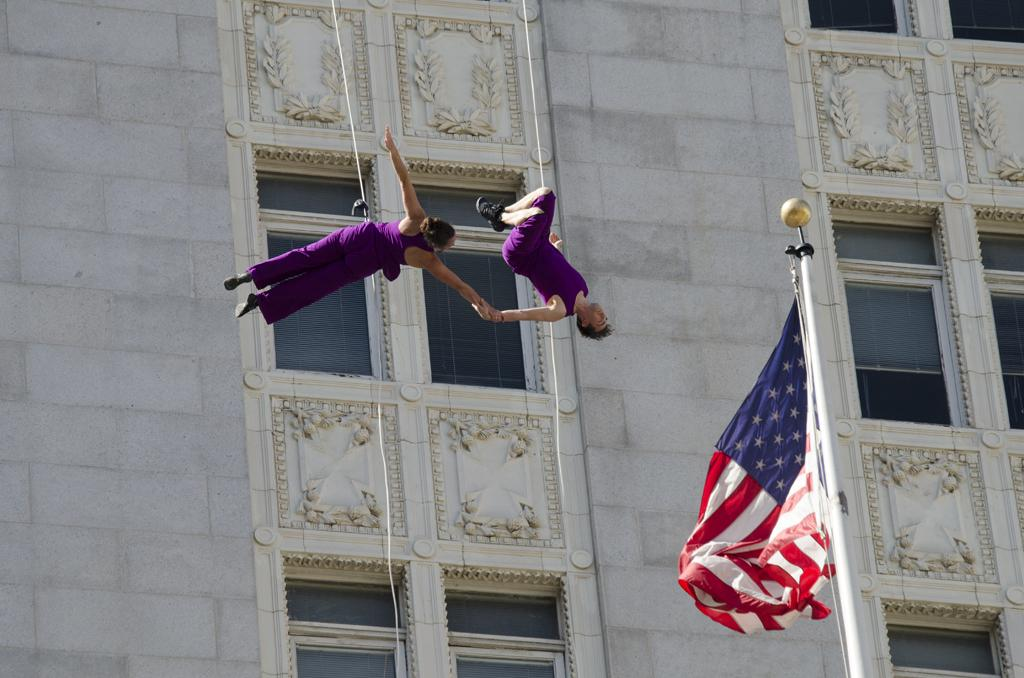What are the two people in the image doing? A: The two people are in the air, which suggests they might be flying or performing an activity that involves being suspended. What can be seen connecting the people to the ground or another object in the image? Ropes are visible in the image, which might be used to support or suspend the people. What is the background of the image composed of? There is a wall in the image, which could be the surface the people are attached to or the backdrop of the scene. Are there any openings in the wall? Yes, windows are present in the image, which are openings in the wall. What is attached to the pole in the image? There is a flag in the image, which is attached to the pole. What is on the wall that adds decorative or artistic detail? Carvings are visible on the walls, which provide decoration or artistic detail. What type of vegetable is being used to hold the flag in the image? There is no vegetable present in the image; the flag is attached to a pole. 